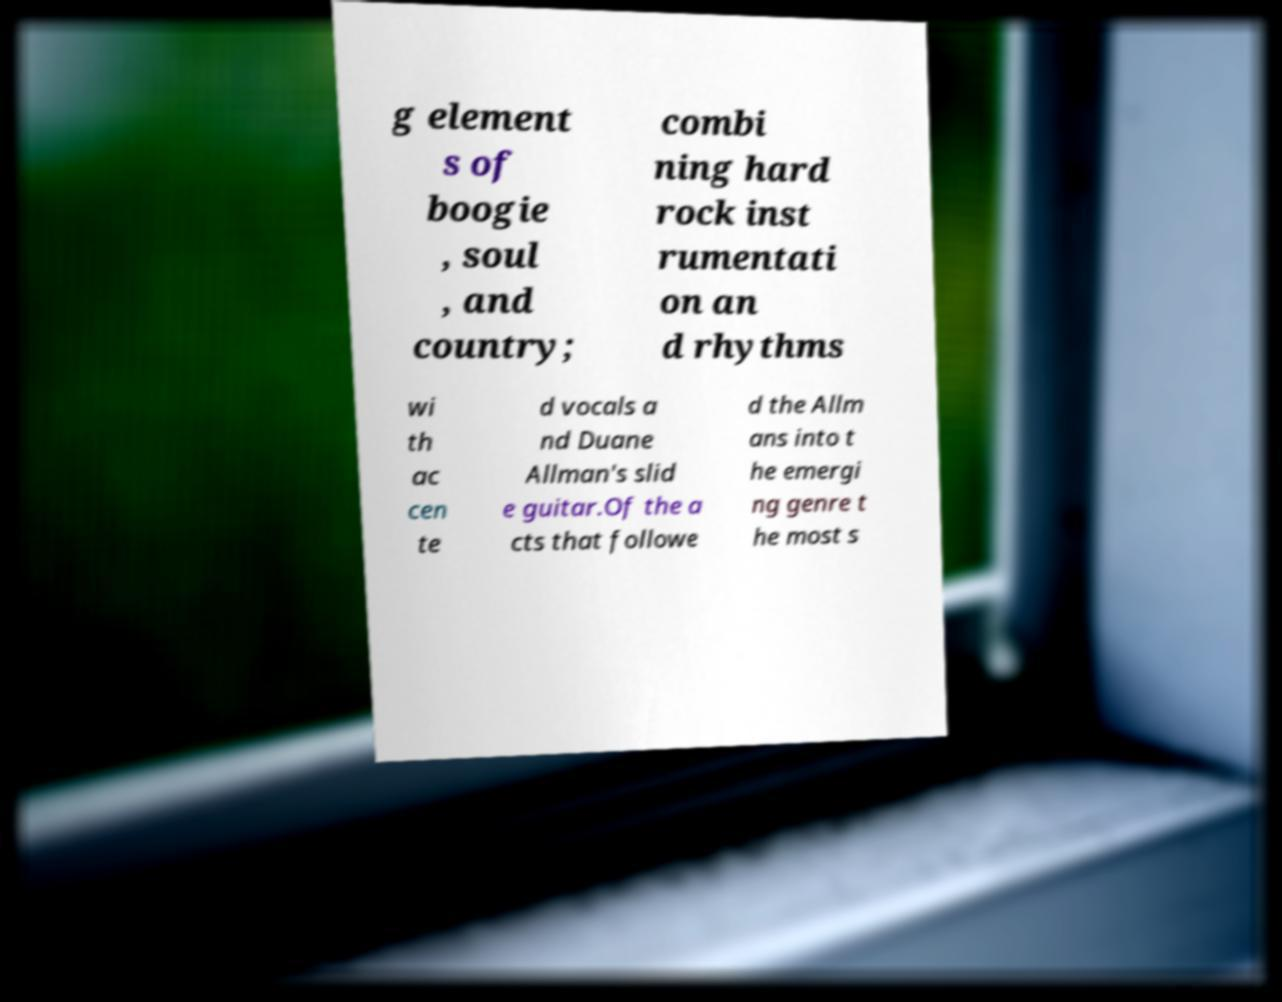Could you extract and type out the text from this image? g element s of boogie , soul , and country; combi ning hard rock inst rumentati on an d rhythms wi th ac cen te d vocals a nd Duane Allman's slid e guitar.Of the a cts that followe d the Allm ans into t he emergi ng genre t he most s 